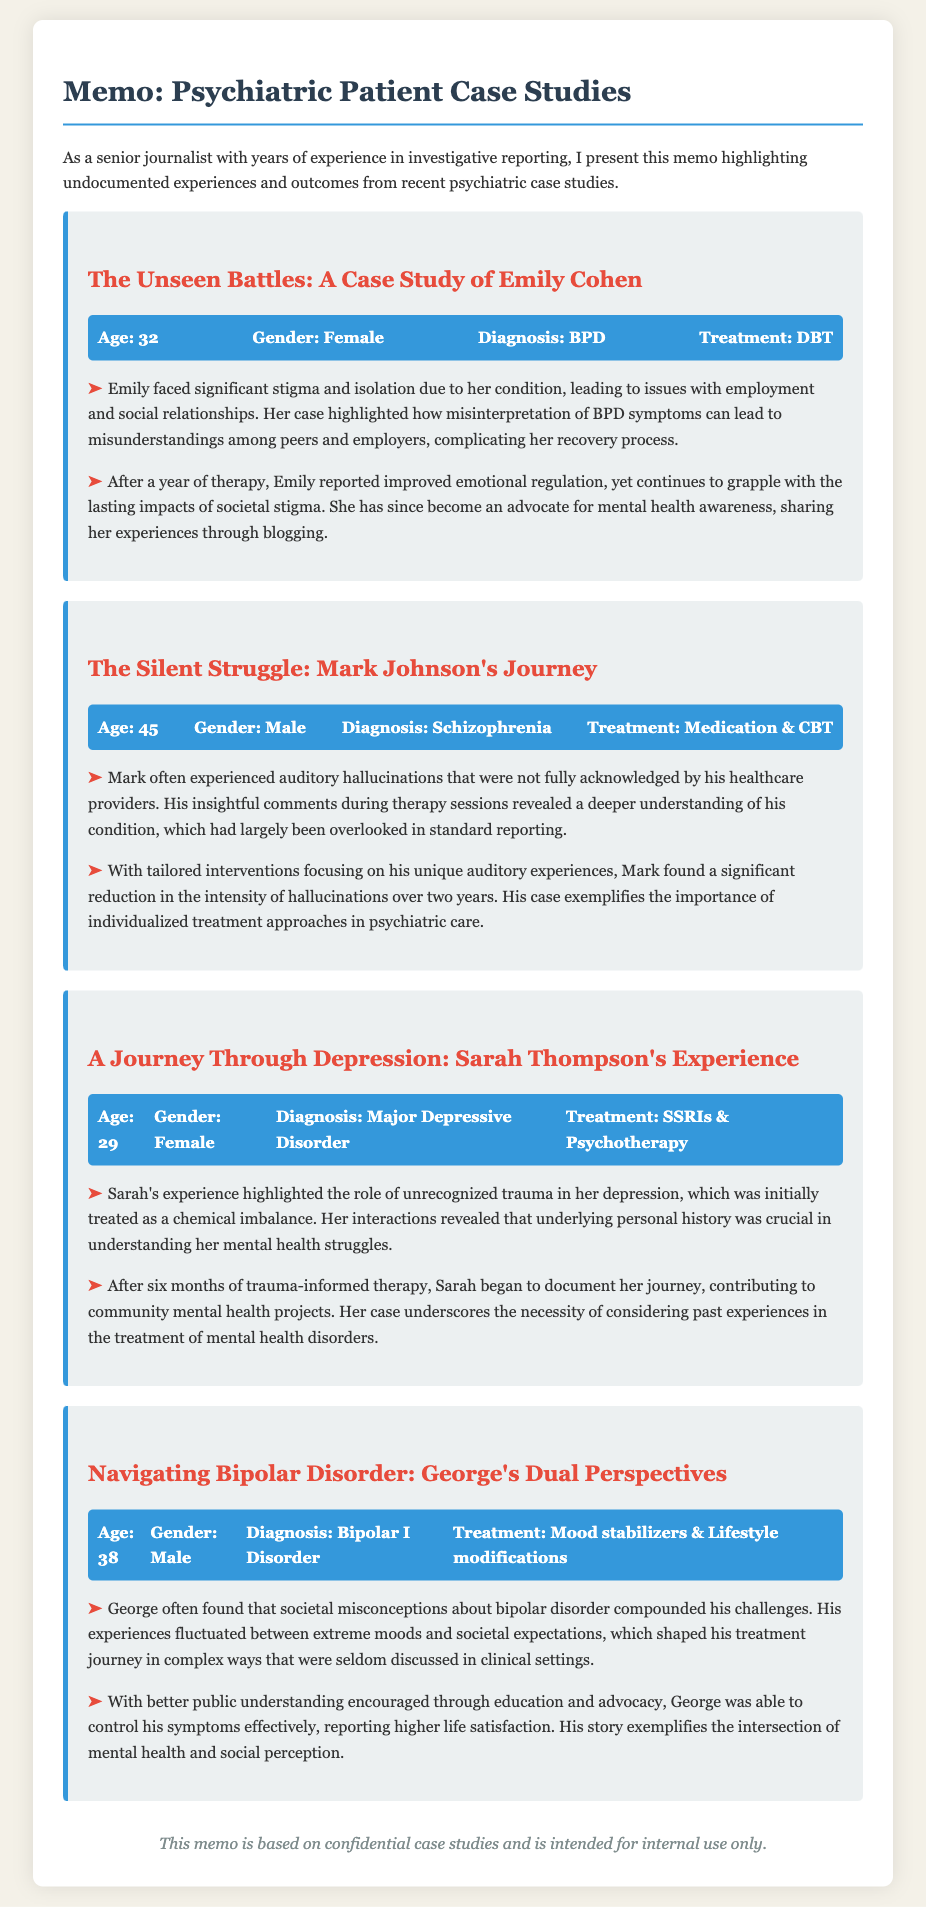What is Emily Cohen's age? The document provides Emily's age as part of the patient information section, which is 32.
Answer: 32 What diagnosis does Mark Johnson have? The memo lists Mark's diagnosis explicitly under his patient information, which is Schizophrenia.
Answer: Schizophrenia How long did Sarah undergo trauma-informed therapy? The memo states that Sarah began her therapy and documented her journey after six months.
Answer: Six months What treatment did George receive for his condition? George's treatment is specified as Mood stabilizers & Lifestyle modifications in the case study.
Answer: Mood stabilizers & Lifestyle modifications What overarching theme is emphasized in Emily Cohen's story? The document highlights the stigma and isolation experienced by Emily due to her condition, which is a significant theme in her case.
Answer: Stigma and isolation How did Mark's auditory hallucinations affect his treatment? The memo indicates that Mark's insights about his auditory hallucinations led to tailored interventions, thus influencing the effectiveness of his treatment.
Answer: Tailored interventions What writing contribution did Sarah make after her therapy? The document mentions that Sarah contributed to community mental health projects, showcasing her engagements post-therapy.
Answer: Community mental health projects Which disorder is associated with the patient George? The memo states that George is associated with Bipolar I Disorder, listed under his diagnosis.
Answer: Bipolar I Disorder How did Emily Cohen utilize her experiences post-therapy? The document describes that Emily became an advocate for mental health awareness through blogging after her therapy.
Answer: Advocated through blogging 